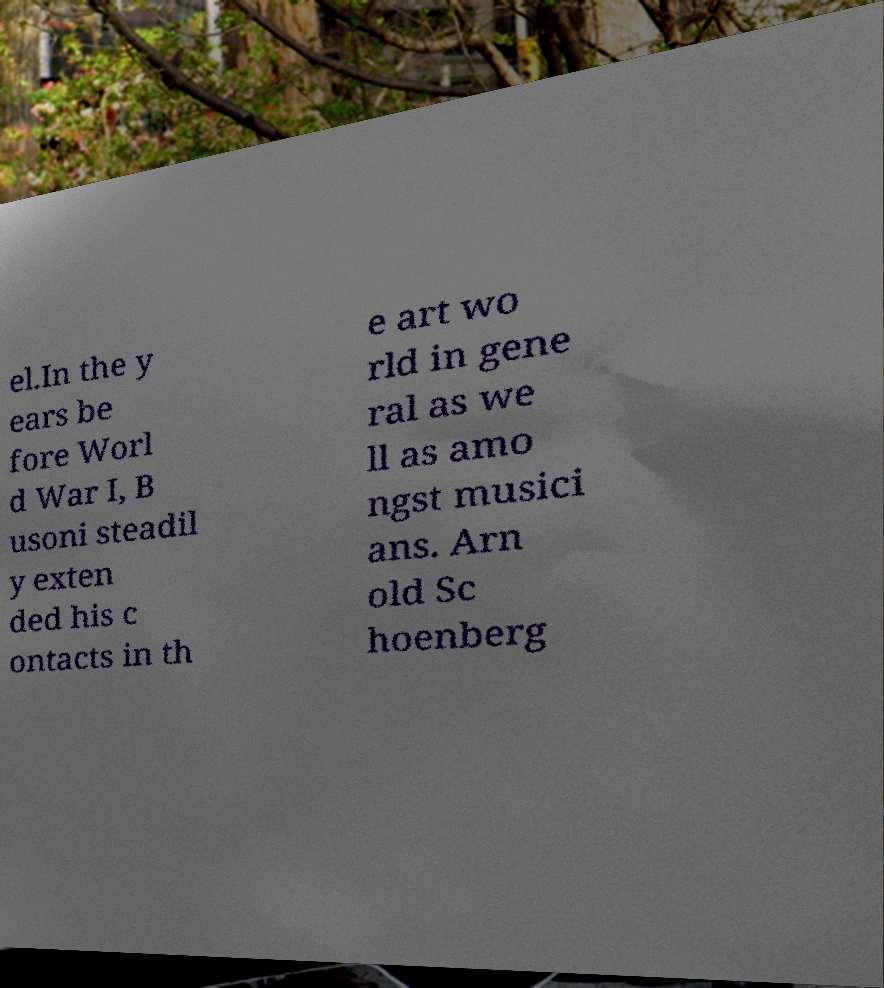What messages or text are displayed in this image? I need them in a readable, typed format. el.In the y ears be fore Worl d War I, B usoni steadil y exten ded his c ontacts in th e art wo rld in gene ral as we ll as amo ngst musici ans. Arn old Sc hoenberg 